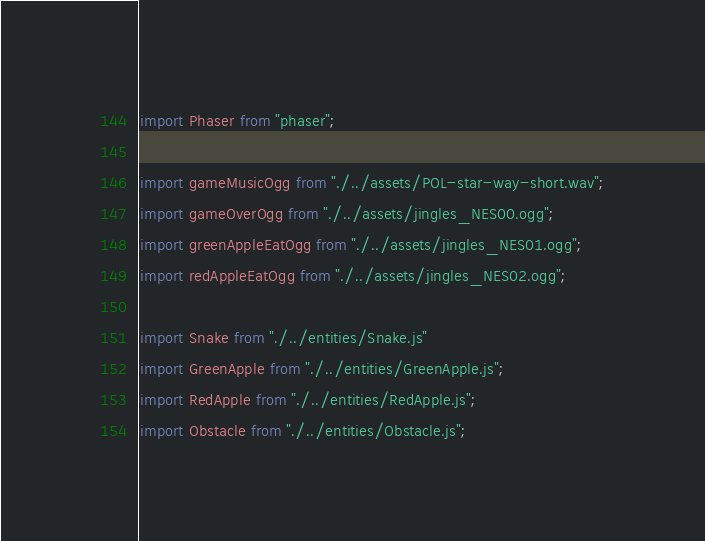<code> <loc_0><loc_0><loc_500><loc_500><_JavaScript_>import Phaser from "phaser";

import gameMusicOgg from "./../assets/POL-star-way-short.wav";
import gameOverOgg from "./../assets/jingles_NES00.ogg";
import greenAppleEatOgg from "./../assets/jingles_NES01.ogg";
import redAppleEatOgg from "./../assets/jingles_NES02.ogg";

import Snake from "./../entities/Snake.js"
import GreenApple from "./../entities/GreenApple.js";
import RedApple from "./../entities/RedApple.js";
import Obstacle from "./../entities/Obstacle.js";
</code> 